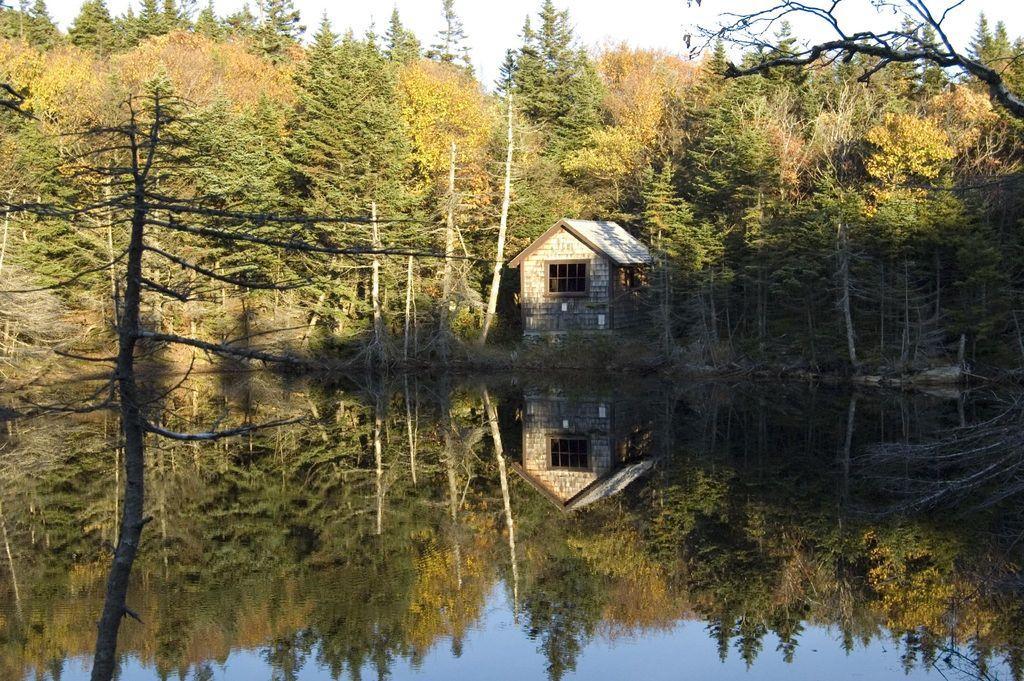How would you summarize this image in a sentence or two? At the bottom of the image there is water. In the background of the image there are trees. There is a house. At the top of the image there is sky. 